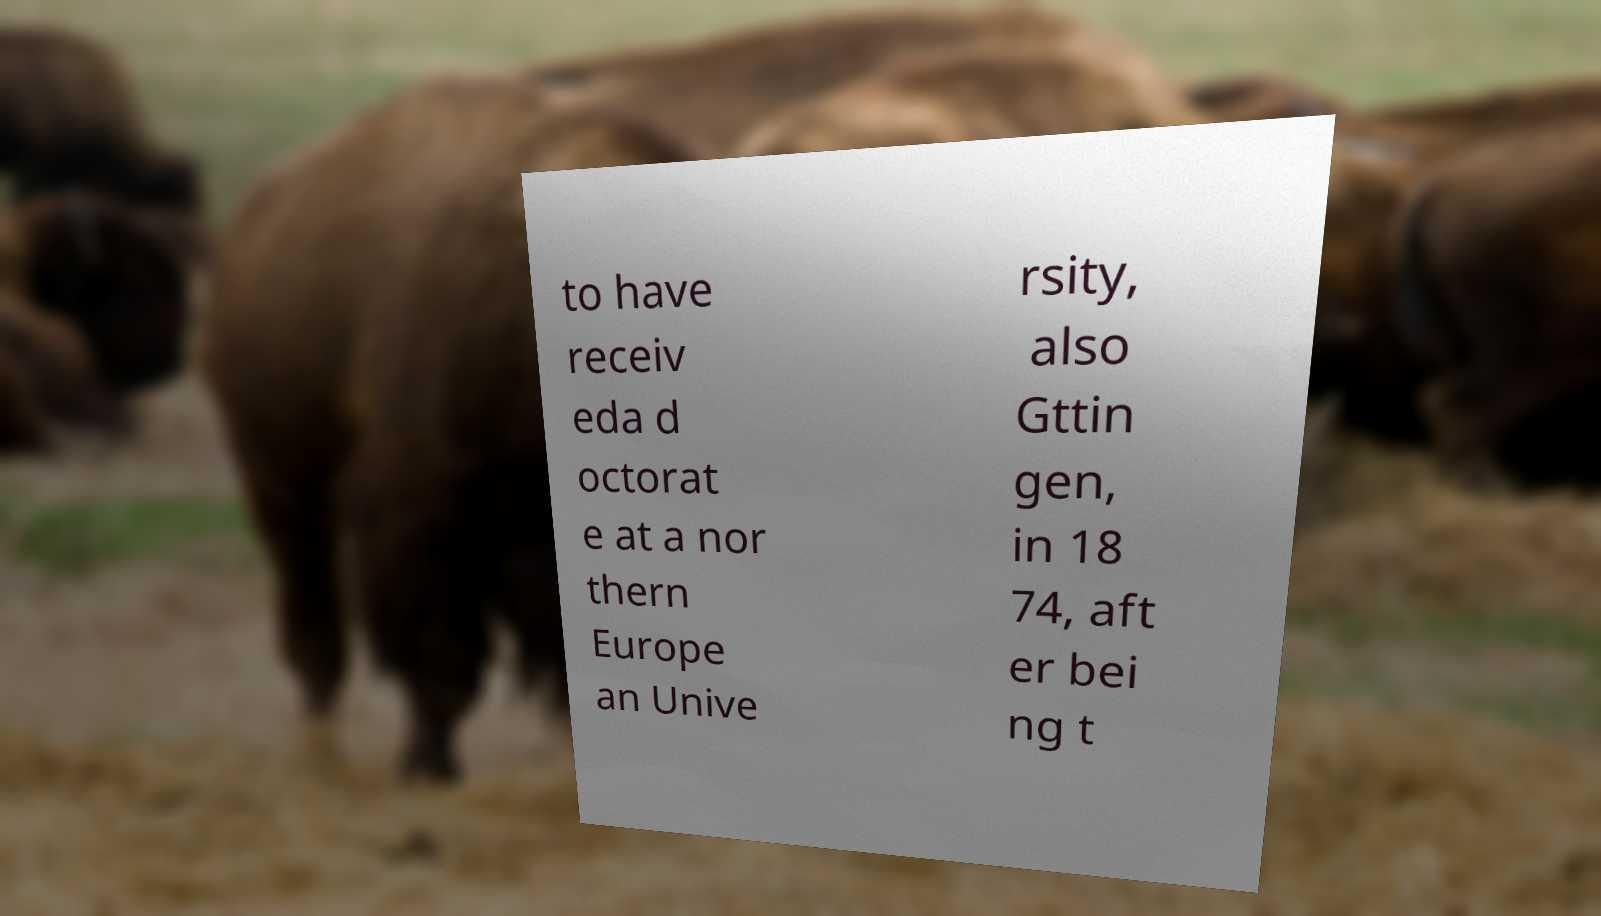For documentation purposes, I need the text within this image transcribed. Could you provide that? to have receiv eda d octorat e at a nor thern Europe an Unive rsity, also Gttin gen, in 18 74, aft er bei ng t 